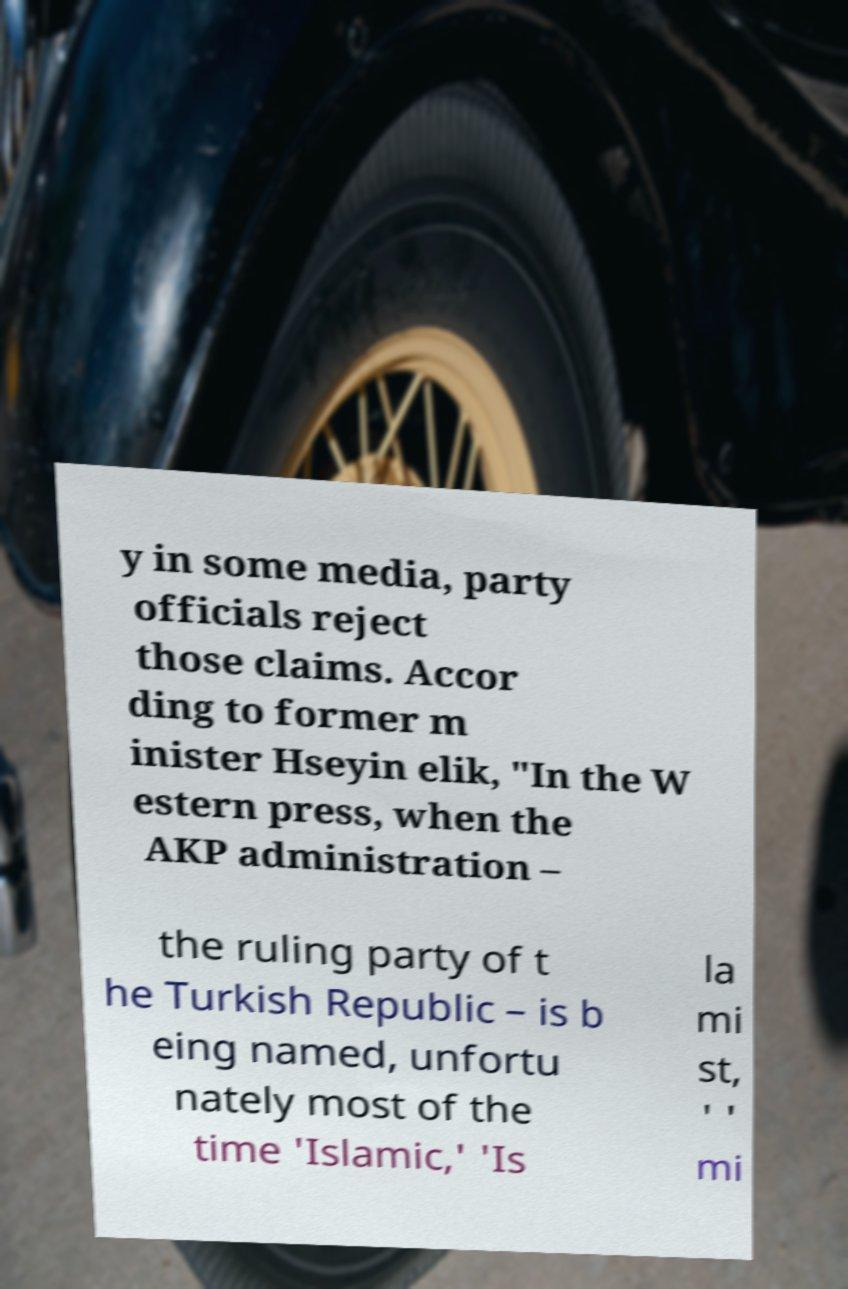For documentation purposes, I need the text within this image transcribed. Could you provide that? y in some media, party officials reject those claims. Accor ding to former m inister Hseyin elik, "In the W estern press, when the AKP administration – the ruling party of t he Turkish Republic – is b eing named, unfortu nately most of the time 'Islamic,' 'Is la mi st, ' ' mi 